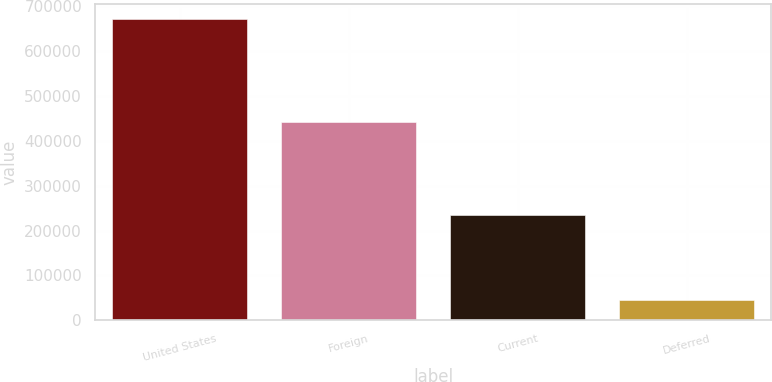Convert chart. <chart><loc_0><loc_0><loc_500><loc_500><bar_chart><fcel>United States<fcel>Foreign<fcel>Current<fcel>Deferred<nl><fcel>672907<fcel>441821<fcel>235557<fcel>45797<nl></chart> 